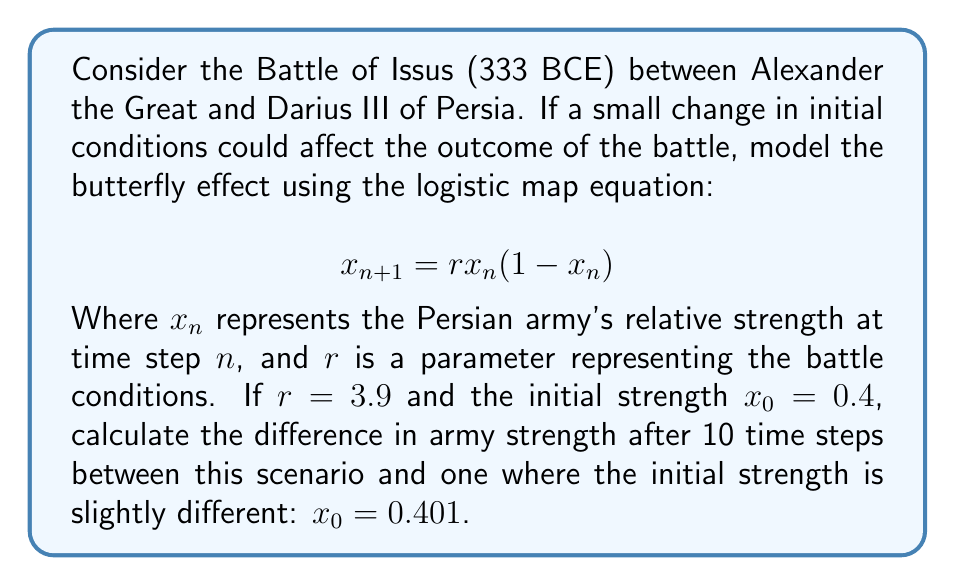Provide a solution to this math problem. To solve this problem, we need to iterate the logistic map equation for both initial conditions and compare the results after 10 steps. Let's calculate step-by-step:

1. For $x_0 = 0.4$:
   $x_1 = 3.9 \cdot 0.4 \cdot (1-0.4) = 0.936$
   $x_2 = 3.9 \cdot 0.936 \cdot (1-0.936) = 0.234$
   $x_3 = 3.9 \cdot 0.234 \cdot (1-0.234) = 0.700$
   ...
   $x_{10} = 0.886$

2. For $x_0 = 0.401$:
   $x_1 = 3.9 \cdot 0.401 \cdot (1-0.401) = 0.938$
   $x_2 = 3.9 \cdot 0.938 \cdot (1-0.938) = 0.227$
   $x_3 = 3.9 \cdot 0.227 \cdot (1-0.227) = 0.684$
   ...
   $x_{10} = 0.506$

3. Calculate the difference:
   $|x_{10}(0.4) - x_{10}(0.401)| = |0.886 - 0.506| = 0.380$

This significant difference after only 10 iterations, despite a tiny initial change, demonstrates the butterfly effect in chaotic systems like warfare.
Answer: 0.380 